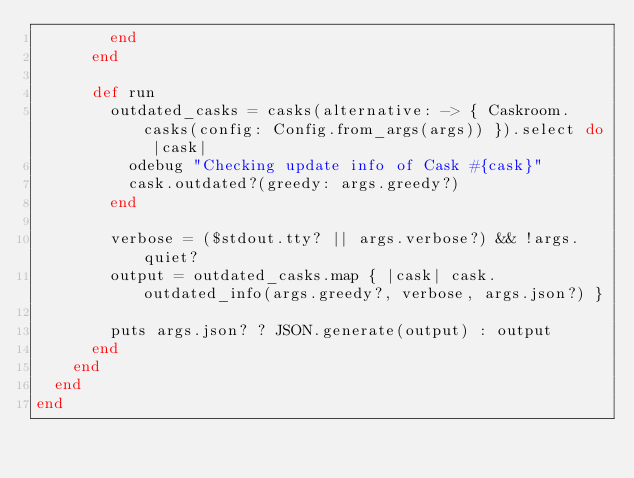Convert code to text. <code><loc_0><loc_0><loc_500><loc_500><_Ruby_>        end
      end

      def run
        outdated_casks = casks(alternative: -> { Caskroom.casks(config: Config.from_args(args)) }).select do |cask|
          odebug "Checking update info of Cask #{cask}"
          cask.outdated?(greedy: args.greedy?)
        end

        verbose = ($stdout.tty? || args.verbose?) && !args.quiet?
        output = outdated_casks.map { |cask| cask.outdated_info(args.greedy?, verbose, args.json?) }

        puts args.json? ? JSON.generate(output) : output
      end
    end
  end
end
</code> 